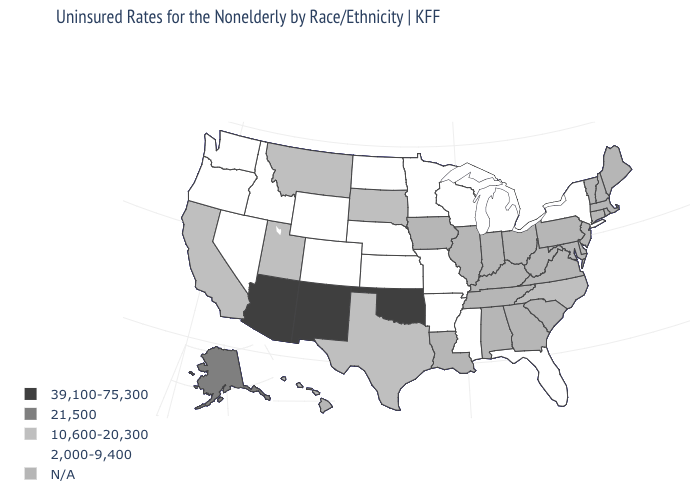What is the value of California?
Keep it brief. 10,600-20,300. What is the value of North Dakota?
Write a very short answer. 2,000-9,400. Does Wisconsin have the lowest value in the USA?
Write a very short answer. Yes. What is the value of Florida?
Concise answer only. 2,000-9,400. What is the highest value in states that border Kansas?
Short answer required. 39,100-75,300. What is the highest value in the West ?
Concise answer only. 39,100-75,300. Name the states that have a value in the range 2,000-9,400?
Be succinct. Arkansas, Colorado, Florida, Idaho, Kansas, Michigan, Minnesota, Mississippi, Missouri, Nebraska, Nevada, New York, North Dakota, Oregon, Washington, Wisconsin, Wyoming. Name the states that have a value in the range 39,100-75,300?
Keep it brief. Arizona, New Mexico, Oklahoma. How many symbols are there in the legend?
Answer briefly. 5. Name the states that have a value in the range 39,100-75,300?
Be succinct. Arizona, New Mexico, Oklahoma. What is the value of Minnesota?
Keep it brief. 2,000-9,400. What is the value of Wisconsin?
Concise answer only. 2,000-9,400. 